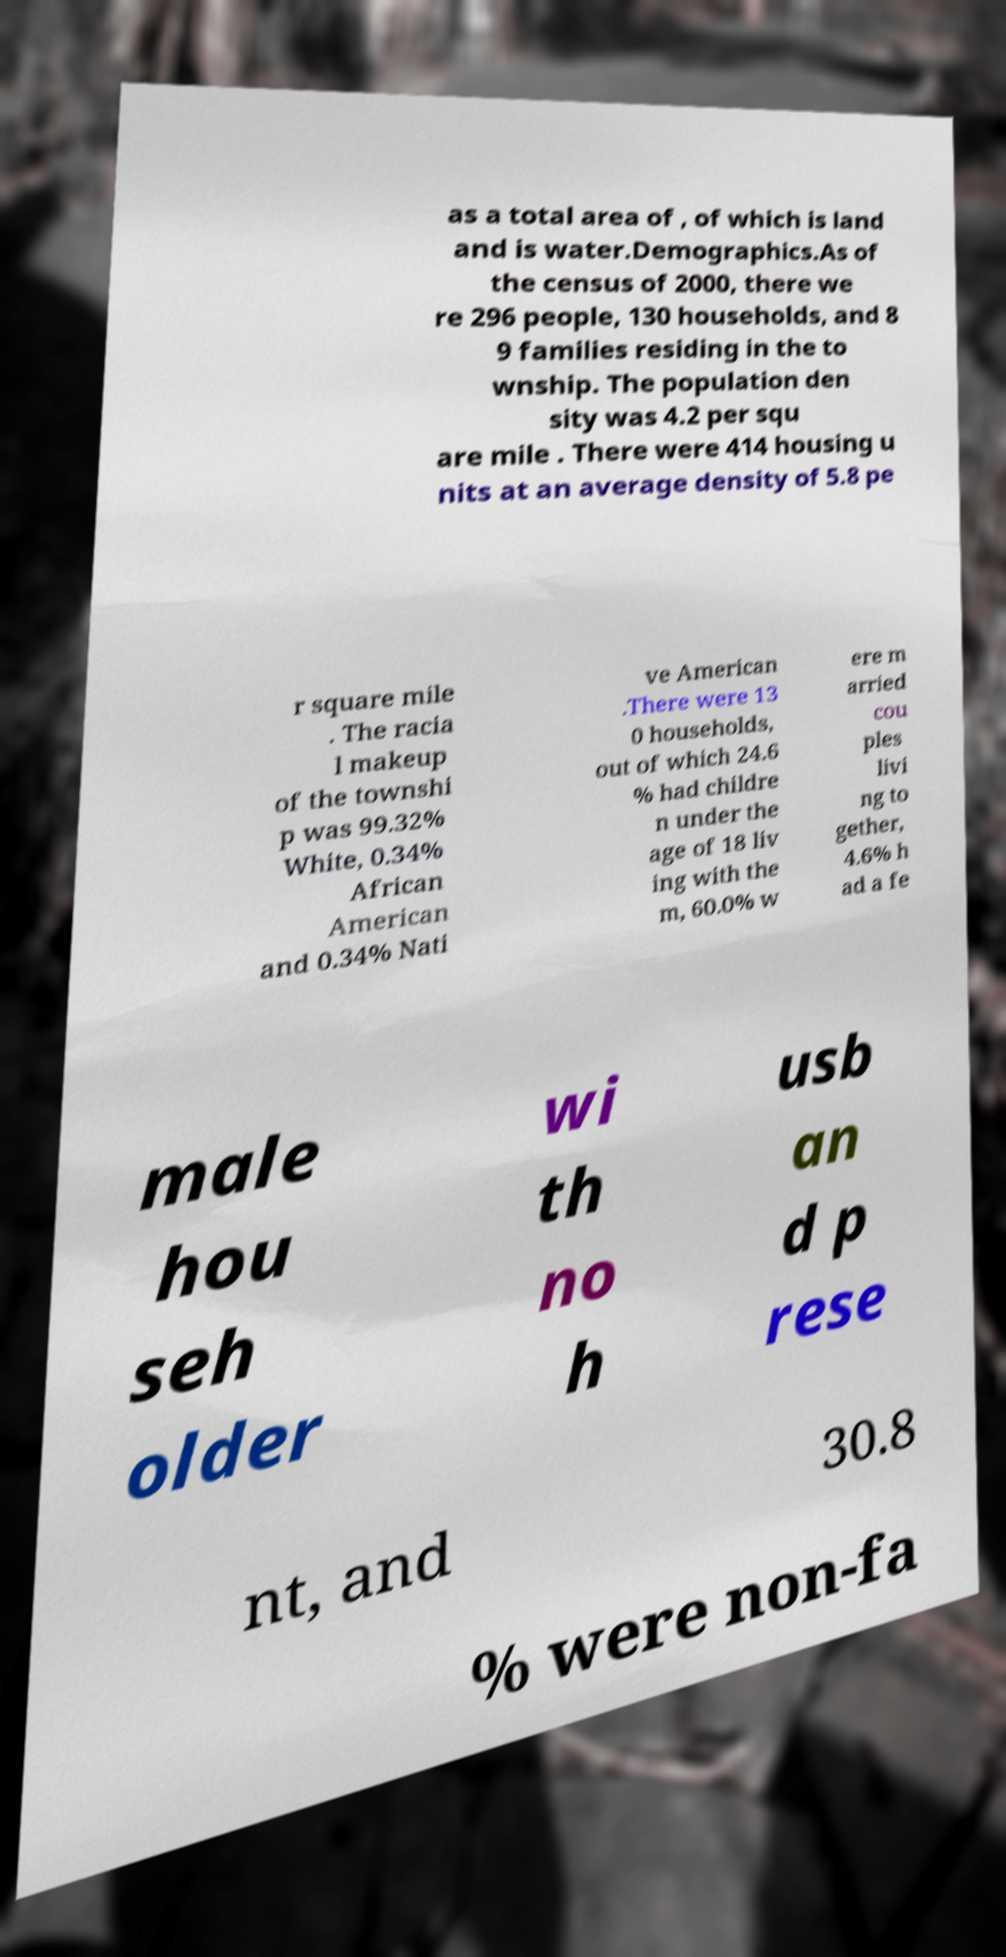What messages or text are displayed in this image? I need them in a readable, typed format. as a total area of , of which is land and is water.Demographics.As of the census of 2000, there we re 296 people, 130 households, and 8 9 families residing in the to wnship. The population den sity was 4.2 per squ are mile . There were 414 housing u nits at an average density of 5.8 pe r square mile . The racia l makeup of the townshi p was 99.32% White, 0.34% African American and 0.34% Nati ve American .There were 13 0 households, out of which 24.6 % had childre n under the age of 18 liv ing with the m, 60.0% w ere m arried cou ples livi ng to gether, 4.6% h ad a fe male hou seh older wi th no h usb an d p rese nt, and 30.8 % were non-fa 